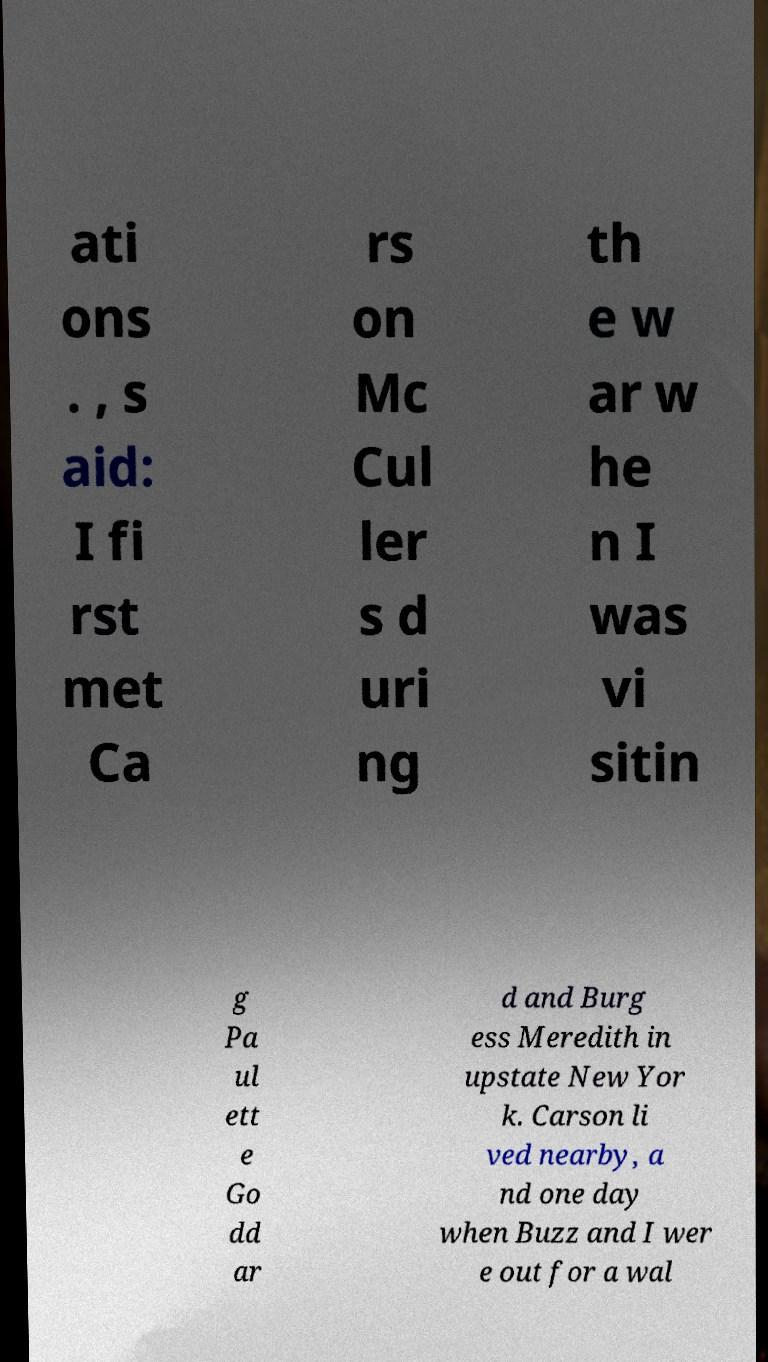Could you extract and type out the text from this image? ati ons . , s aid: I fi rst met Ca rs on Mc Cul ler s d uri ng th e w ar w he n I was vi sitin g Pa ul ett e Go dd ar d and Burg ess Meredith in upstate New Yor k. Carson li ved nearby, a nd one day when Buzz and I wer e out for a wal 